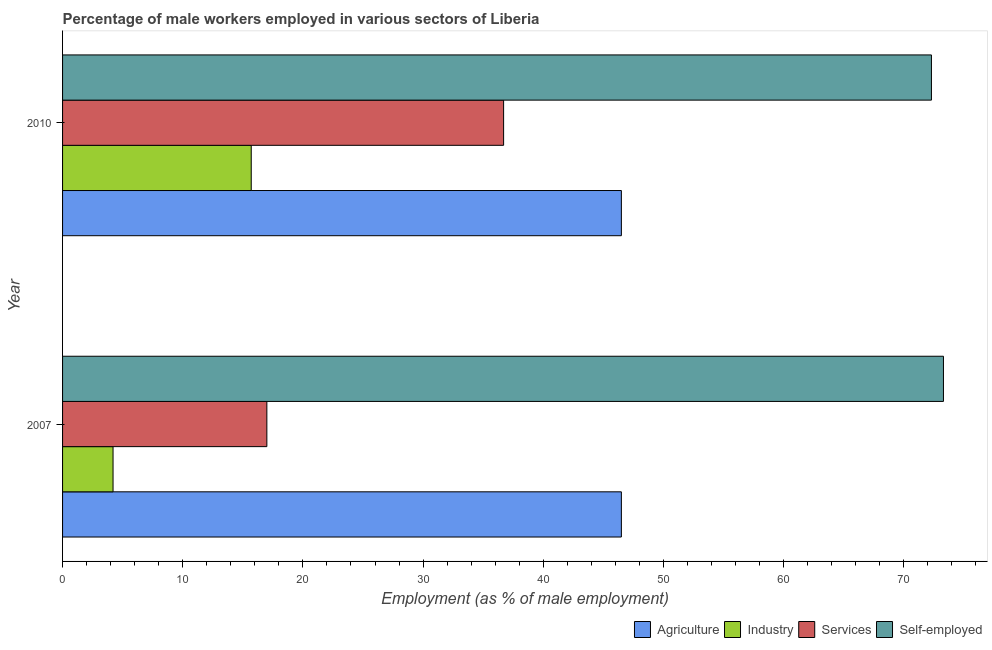In how many cases, is the number of bars for a given year not equal to the number of legend labels?
Your response must be concise. 0. What is the percentage of self employed male workers in 2010?
Give a very brief answer. 72.3. Across all years, what is the maximum percentage of male workers in services?
Offer a very short reply. 36.7. Across all years, what is the minimum percentage of male workers in industry?
Give a very brief answer. 4.2. In which year was the percentage of male workers in services maximum?
Offer a very short reply. 2010. What is the total percentage of male workers in services in the graph?
Provide a short and direct response. 53.7. What is the difference between the percentage of male workers in industry in 2007 and that in 2010?
Your response must be concise. -11.5. What is the difference between the percentage of self employed male workers in 2010 and the percentage of male workers in services in 2007?
Offer a terse response. 55.3. What is the average percentage of self employed male workers per year?
Give a very brief answer. 72.8. In the year 2007, what is the difference between the percentage of male workers in industry and percentage of male workers in services?
Your answer should be very brief. -12.8. In how many years, is the percentage of male workers in industry greater than 42 %?
Keep it short and to the point. 0. What is the ratio of the percentage of male workers in agriculture in 2007 to that in 2010?
Provide a succinct answer. 1. In how many years, is the percentage of male workers in services greater than the average percentage of male workers in services taken over all years?
Keep it short and to the point. 1. What does the 1st bar from the top in 2010 represents?
Keep it short and to the point. Self-employed. What does the 1st bar from the bottom in 2007 represents?
Offer a terse response. Agriculture. How many bars are there?
Provide a short and direct response. 8. How many years are there in the graph?
Your answer should be very brief. 2. What is the difference between two consecutive major ticks on the X-axis?
Keep it short and to the point. 10. Are the values on the major ticks of X-axis written in scientific E-notation?
Give a very brief answer. No. Does the graph contain grids?
Make the answer very short. No. Where does the legend appear in the graph?
Make the answer very short. Bottom right. How are the legend labels stacked?
Offer a very short reply. Horizontal. What is the title of the graph?
Your answer should be very brief. Percentage of male workers employed in various sectors of Liberia. Does "United States" appear as one of the legend labels in the graph?
Your response must be concise. No. What is the label or title of the X-axis?
Your answer should be compact. Employment (as % of male employment). What is the Employment (as % of male employment) of Agriculture in 2007?
Offer a very short reply. 46.5. What is the Employment (as % of male employment) in Industry in 2007?
Keep it short and to the point. 4.2. What is the Employment (as % of male employment) of Self-employed in 2007?
Give a very brief answer. 73.3. What is the Employment (as % of male employment) in Agriculture in 2010?
Give a very brief answer. 46.5. What is the Employment (as % of male employment) of Industry in 2010?
Offer a very short reply. 15.7. What is the Employment (as % of male employment) in Services in 2010?
Your answer should be compact. 36.7. What is the Employment (as % of male employment) of Self-employed in 2010?
Your answer should be compact. 72.3. Across all years, what is the maximum Employment (as % of male employment) in Agriculture?
Make the answer very short. 46.5. Across all years, what is the maximum Employment (as % of male employment) in Industry?
Give a very brief answer. 15.7. Across all years, what is the maximum Employment (as % of male employment) in Services?
Provide a short and direct response. 36.7. Across all years, what is the maximum Employment (as % of male employment) of Self-employed?
Your answer should be very brief. 73.3. Across all years, what is the minimum Employment (as % of male employment) of Agriculture?
Keep it short and to the point. 46.5. Across all years, what is the minimum Employment (as % of male employment) in Industry?
Provide a short and direct response. 4.2. Across all years, what is the minimum Employment (as % of male employment) in Self-employed?
Keep it short and to the point. 72.3. What is the total Employment (as % of male employment) in Agriculture in the graph?
Your answer should be very brief. 93. What is the total Employment (as % of male employment) of Industry in the graph?
Give a very brief answer. 19.9. What is the total Employment (as % of male employment) in Services in the graph?
Keep it short and to the point. 53.7. What is the total Employment (as % of male employment) in Self-employed in the graph?
Offer a very short reply. 145.6. What is the difference between the Employment (as % of male employment) in Agriculture in 2007 and that in 2010?
Provide a short and direct response. 0. What is the difference between the Employment (as % of male employment) in Industry in 2007 and that in 2010?
Your answer should be compact. -11.5. What is the difference between the Employment (as % of male employment) in Services in 2007 and that in 2010?
Your response must be concise. -19.7. What is the difference between the Employment (as % of male employment) of Agriculture in 2007 and the Employment (as % of male employment) of Industry in 2010?
Your response must be concise. 30.8. What is the difference between the Employment (as % of male employment) in Agriculture in 2007 and the Employment (as % of male employment) in Self-employed in 2010?
Ensure brevity in your answer.  -25.8. What is the difference between the Employment (as % of male employment) in Industry in 2007 and the Employment (as % of male employment) in Services in 2010?
Give a very brief answer. -32.5. What is the difference between the Employment (as % of male employment) in Industry in 2007 and the Employment (as % of male employment) in Self-employed in 2010?
Your answer should be compact. -68.1. What is the difference between the Employment (as % of male employment) of Services in 2007 and the Employment (as % of male employment) of Self-employed in 2010?
Offer a very short reply. -55.3. What is the average Employment (as % of male employment) in Agriculture per year?
Keep it short and to the point. 46.5. What is the average Employment (as % of male employment) in Industry per year?
Your response must be concise. 9.95. What is the average Employment (as % of male employment) in Services per year?
Your response must be concise. 26.85. What is the average Employment (as % of male employment) of Self-employed per year?
Give a very brief answer. 72.8. In the year 2007, what is the difference between the Employment (as % of male employment) in Agriculture and Employment (as % of male employment) in Industry?
Make the answer very short. 42.3. In the year 2007, what is the difference between the Employment (as % of male employment) in Agriculture and Employment (as % of male employment) in Services?
Provide a succinct answer. 29.5. In the year 2007, what is the difference between the Employment (as % of male employment) in Agriculture and Employment (as % of male employment) in Self-employed?
Ensure brevity in your answer.  -26.8. In the year 2007, what is the difference between the Employment (as % of male employment) of Industry and Employment (as % of male employment) of Services?
Offer a very short reply. -12.8. In the year 2007, what is the difference between the Employment (as % of male employment) in Industry and Employment (as % of male employment) in Self-employed?
Ensure brevity in your answer.  -69.1. In the year 2007, what is the difference between the Employment (as % of male employment) of Services and Employment (as % of male employment) of Self-employed?
Keep it short and to the point. -56.3. In the year 2010, what is the difference between the Employment (as % of male employment) of Agriculture and Employment (as % of male employment) of Industry?
Give a very brief answer. 30.8. In the year 2010, what is the difference between the Employment (as % of male employment) of Agriculture and Employment (as % of male employment) of Services?
Give a very brief answer. 9.8. In the year 2010, what is the difference between the Employment (as % of male employment) in Agriculture and Employment (as % of male employment) in Self-employed?
Your answer should be very brief. -25.8. In the year 2010, what is the difference between the Employment (as % of male employment) of Industry and Employment (as % of male employment) of Services?
Offer a very short reply. -21. In the year 2010, what is the difference between the Employment (as % of male employment) of Industry and Employment (as % of male employment) of Self-employed?
Your response must be concise. -56.6. In the year 2010, what is the difference between the Employment (as % of male employment) in Services and Employment (as % of male employment) in Self-employed?
Your response must be concise. -35.6. What is the ratio of the Employment (as % of male employment) of Agriculture in 2007 to that in 2010?
Provide a short and direct response. 1. What is the ratio of the Employment (as % of male employment) of Industry in 2007 to that in 2010?
Offer a very short reply. 0.27. What is the ratio of the Employment (as % of male employment) of Services in 2007 to that in 2010?
Keep it short and to the point. 0.46. What is the ratio of the Employment (as % of male employment) in Self-employed in 2007 to that in 2010?
Your response must be concise. 1.01. What is the difference between the highest and the second highest Employment (as % of male employment) in Agriculture?
Provide a short and direct response. 0. What is the difference between the highest and the second highest Employment (as % of male employment) in Industry?
Give a very brief answer. 11.5. What is the difference between the highest and the lowest Employment (as % of male employment) in Self-employed?
Your answer should be compact. 1. 